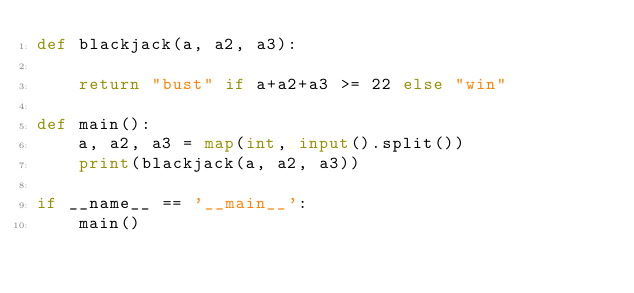Convert code to text. <code><loc_0><loc_0><loc_500><loc_500><_Python_>def blackjack(a, a2, a3):

    return "bust" if a+a2+a3 >= 22 else "win"

def main():
    a, a2, a3 = map(int, input().split())
    print(blackjack(a, a2, a3))

if __name__ == '__main__':
    main()</code> 